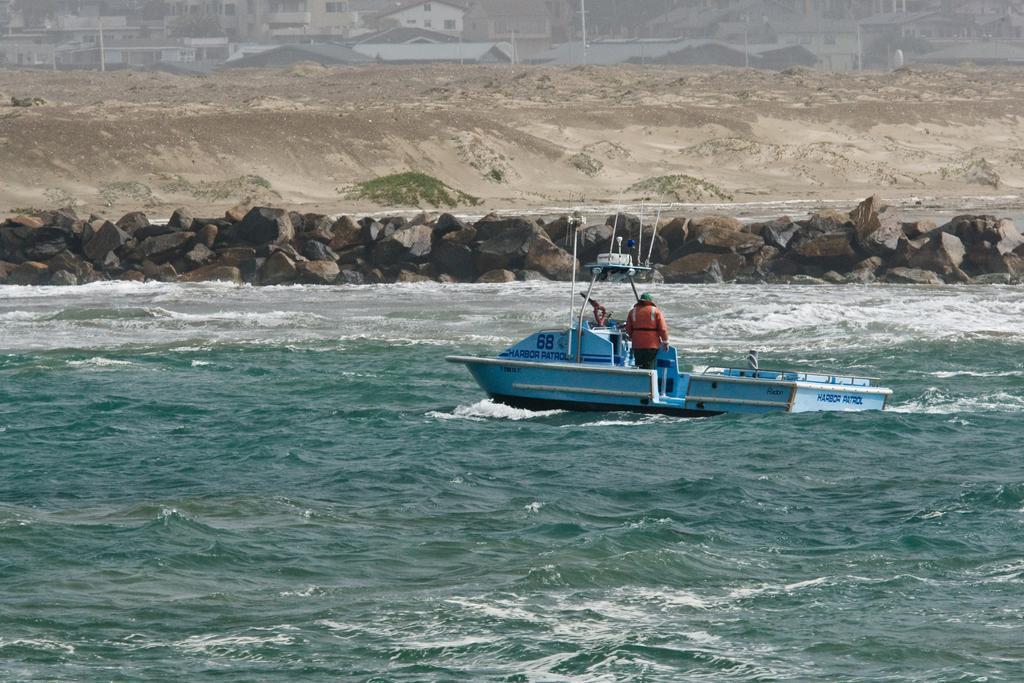Can you describe this image briefly? In this image we can see a person in the boat which is on the surface of the sea. In the background we can see the rocks and also the sand. Image also consists of buildings and also houses. 